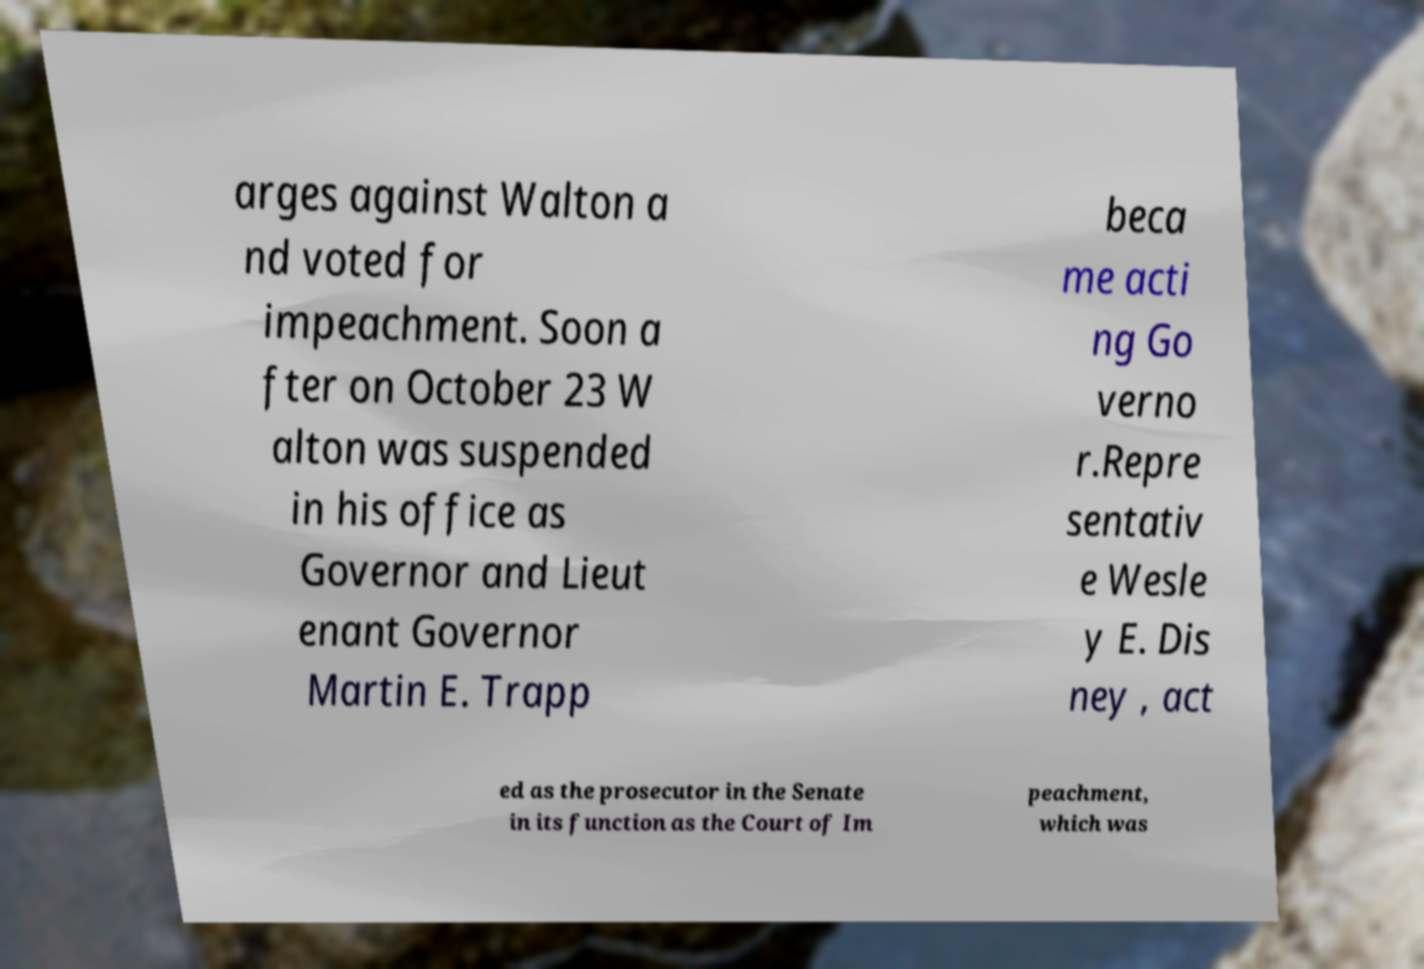Can you read and provide the text displayed in the image?This photo seems to have some interesting text. Can you extract and type it out for me? arges against Walton a nd voted for impeachment. Soon a fter on October 23 W alton was suspended in his office as Governor and Lieut enant Governor Martin E. Trapp beca me acti ng Go verno r.Repre sentativ e Wesle y E. Dis ney , act ed as the prosecutor in the Senate in its function as the Court of Im peachment, which was 